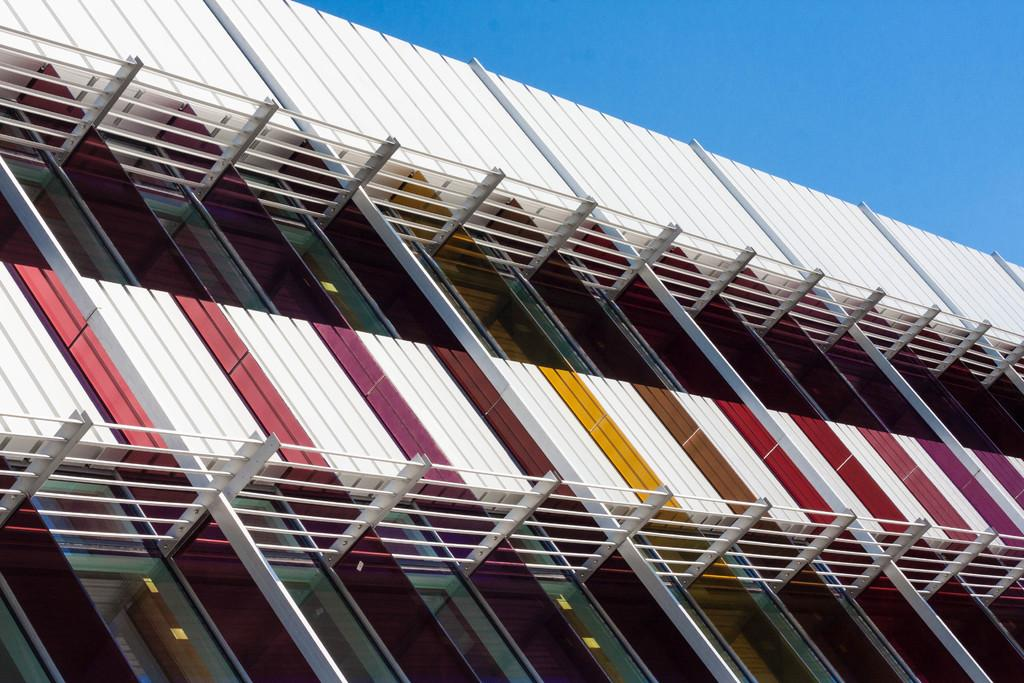What is the main subject of the image? The main subject of the image is the elevation of a building. What material can be seen in the image? Glass and iron poles are visible in the image. What is visible at the top of the image? The sky is visible at the top of the image. What type of coat is being worn by the building in the image? There is no coat present in the image, as the subject is a building and not a person. How many steps does the building take to reach the top in the image? The image does not depict the building taking steps; it shows the elevation of the building. 